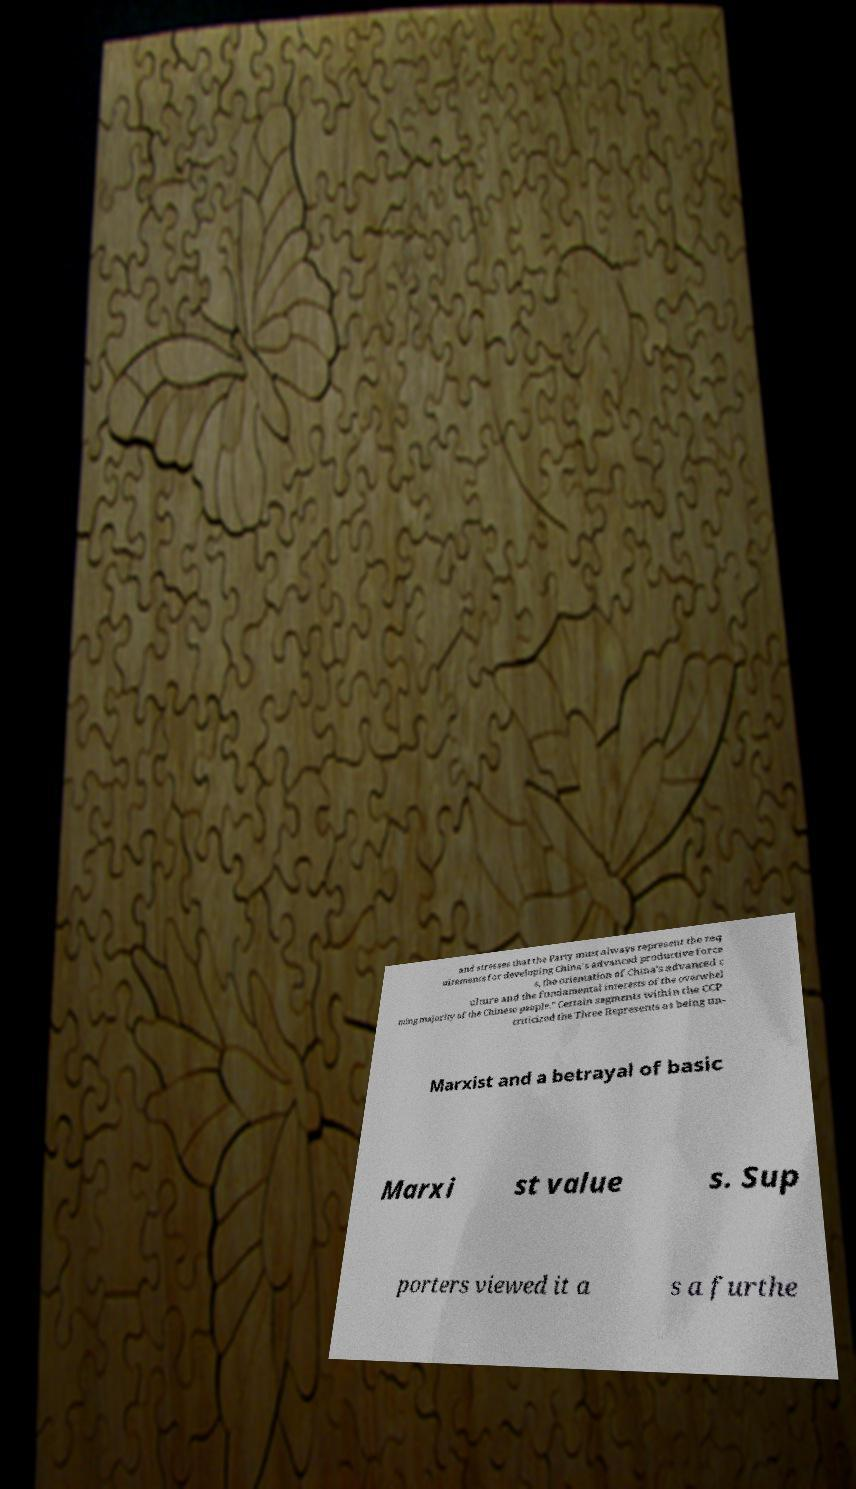I need the written content from this picture converted into text. Can you do that? and stresses that the Party must always represent the req uirements for developing China's advanced productive force s, the orientation of China's advanced c ulture and the fundamental interests of the overwhel ming majority of the Chinese people." Certain segments within the CCP criticized the Three Represents as being un- Marxist and a betrayal of basic Marxi st value s. Sup porters viewed it a s a furthe 